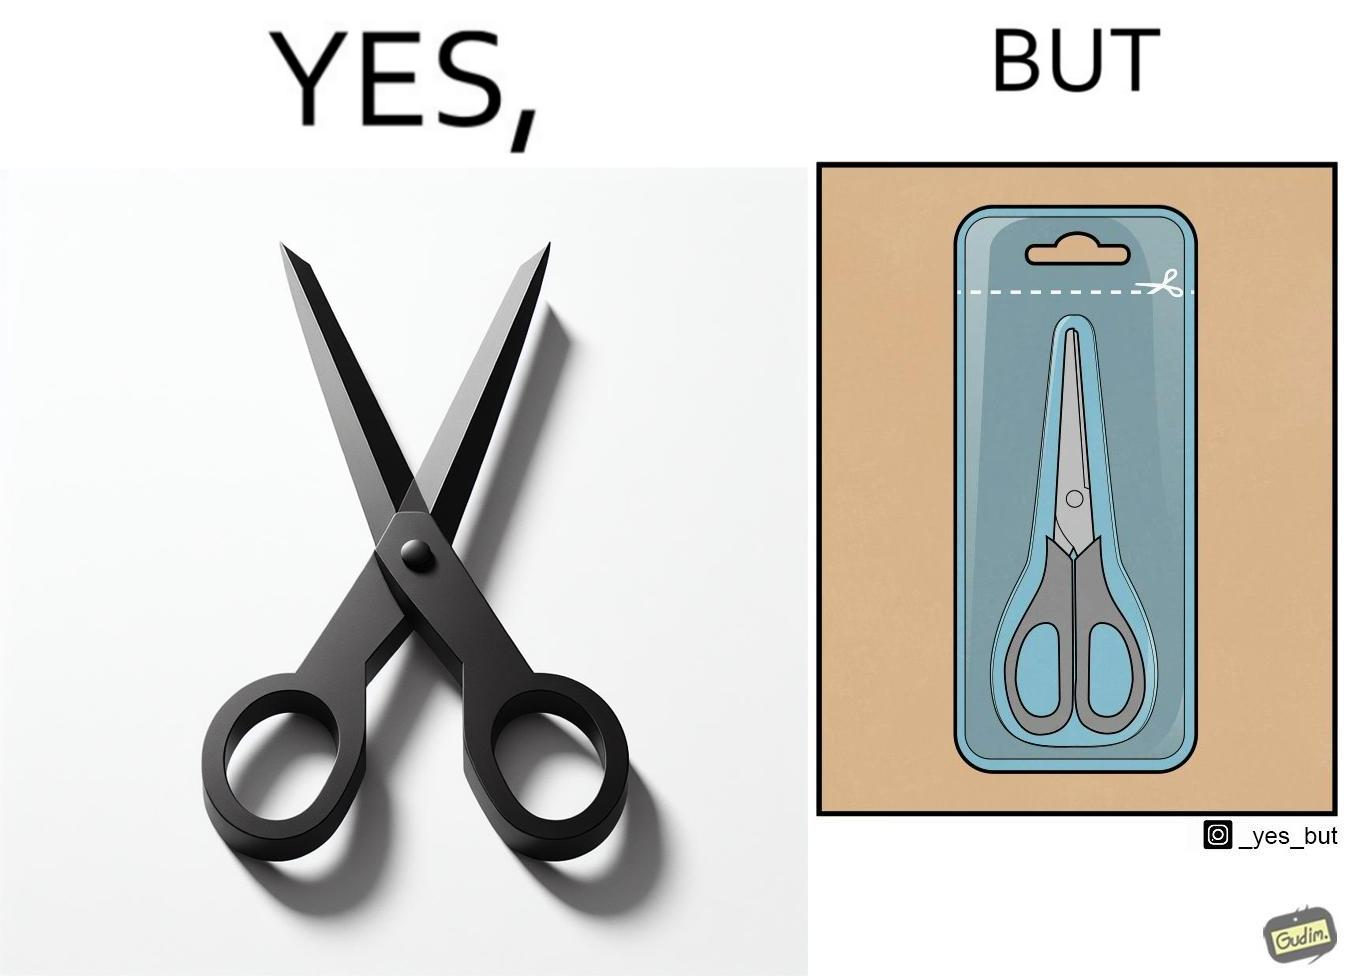Describe the content of this image. the image is funny, as the marking at the top of the packaging shows that you would need a pair of scissors to in-turn cut open the pair of scissors that is inside the packaging. 